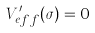Convert formula to latex. <formula><loc_0><loc_0><loc_500><loc_500>V _ { e f f } ^ { \prime } ( \sigma ) = 0</formula> 